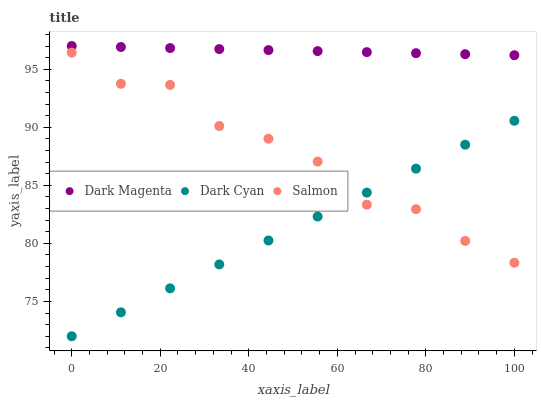Does Dark Cyan have the minimum area under the curve?
Answer yes or no. Yes. Does Dark Magenta have the maximum area under the curve?
Answer yes or no. Yes. Does Salmon have the minimum area under the curve?
Answer yes or no. No. Does Salmon have the maximum area under the curve?
Answer yes or no. No. Is Dark Magenta the smoothest?
Answer yes or no. Yes. Is Salmon the roughest?
Answer yes or no. Yes. Is Salmon the smoothest?
Answer yes or no. No. Is Dark Magenta the roughest?
Answer yes or no. No. Does Dark Cyan have the lowest value?
Answer yes or no. Yes. Does Salmon have the lowest value?
Answer yes or no. No. Does Dark Magenta have the highest value?
Answer yes or no. Yes. Does Salmon have the highest value?
Answer yes or no. No. Is Dark Cyan less than Dark Magenta?
Answer yes or no. Yes. Is Dark Magenta greater than Salmon?
Answer yes or no. Yes. Does Dark Cyan intersect Salmon?
Answer yes or no. Yes. Is Dark Cyan less than Salmon?
Answer yes or no. No. Is Dark Cyan greater than Salmon?
Answer yes or no. No. Does Dark Cyan intersect Dark Magenta?
Answer yes or no. No. 